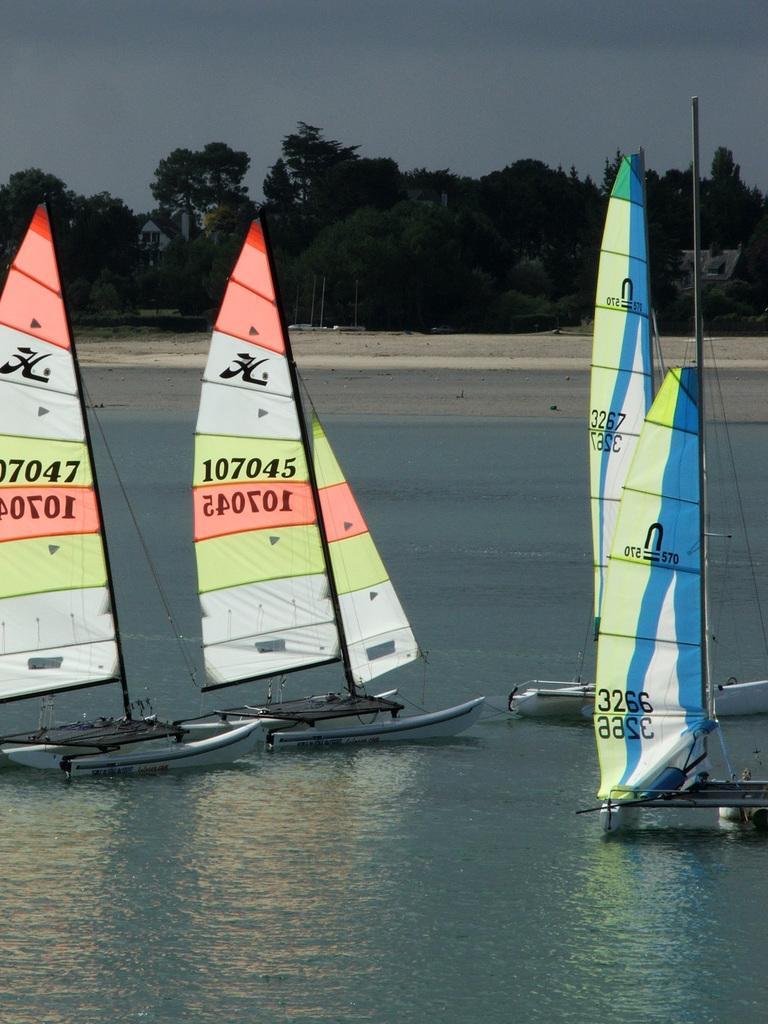In one or two sentences, can you explain what this image depicts? In this image we can see few boats on the water and in the background there are few trees and the sky. 